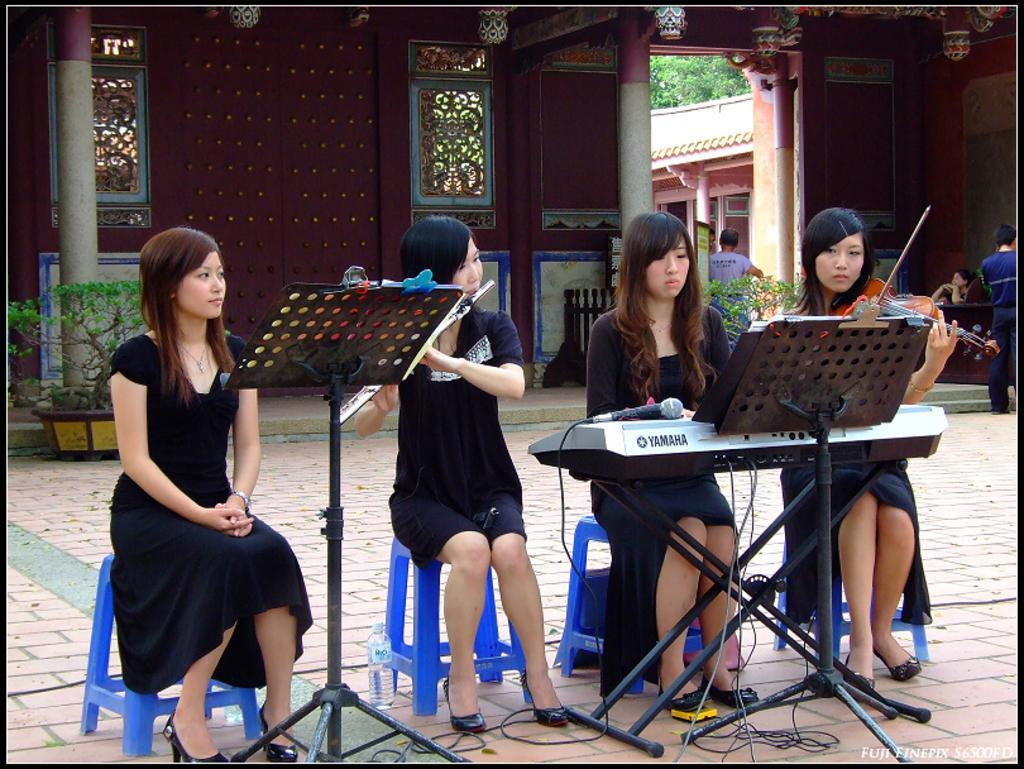How would you summarize this image in a sentence or two? In the picture we can see four woman sitting on the stools on the path and playing music and in front of them we can see a musical keyboard and microphone on it and women are wearing black dresses and behind them we can see a wall and to it we can see windows and some pillars to it and near to it we can see some plant and some people are standing near it and to the wall we can see a exit inside it we can see some pillar and a part of tree. 